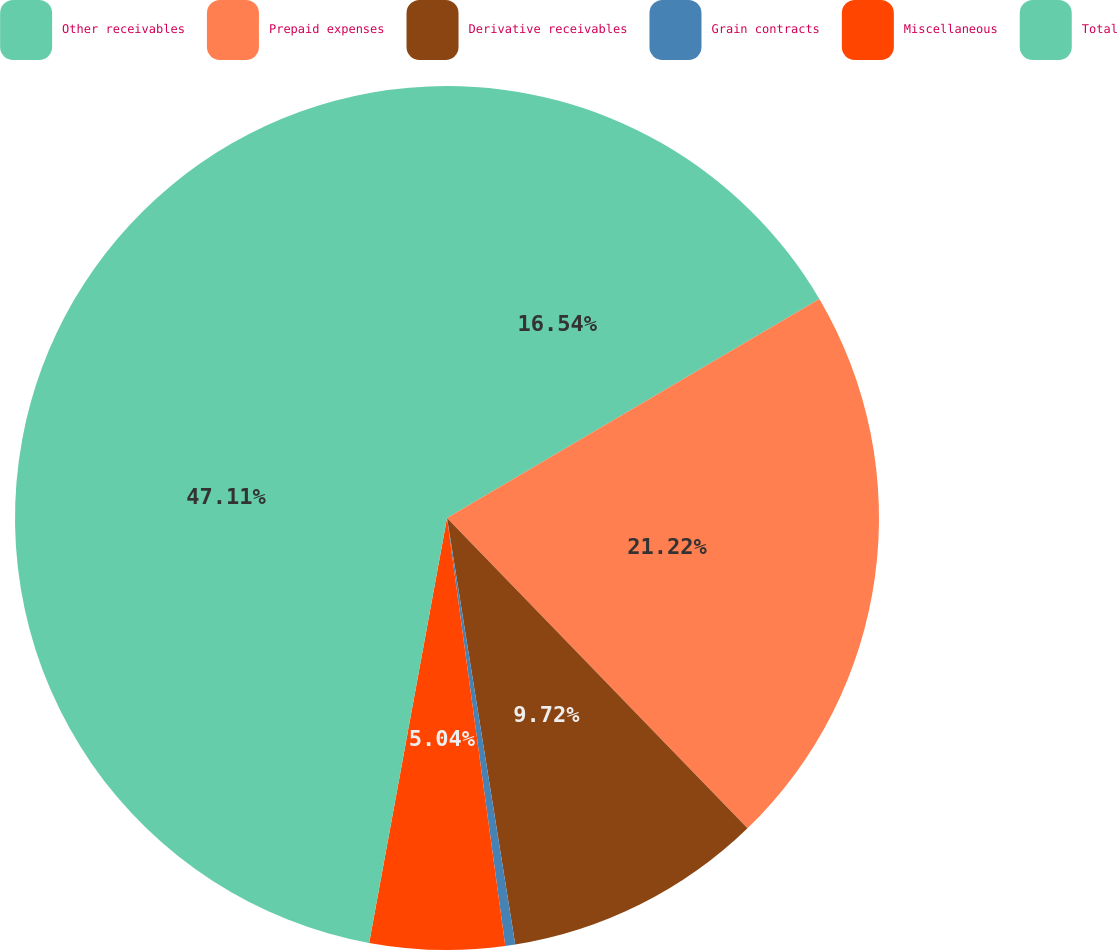<chart> <loc_0><loc_0><loc_500><loc_500><pie_chart><fcel>Other receivables<fcel>Prepaid expenses<fcel>Derivative receivables<fcel>Grain contracts<fcel>Miscellaneous<fcel>Total<nl><fcel>16.54%<fcel>21.22%<fcel>9.72%<fcel>0.37%<fcel>5.04%<fcel>47.12%<nl></chart> 